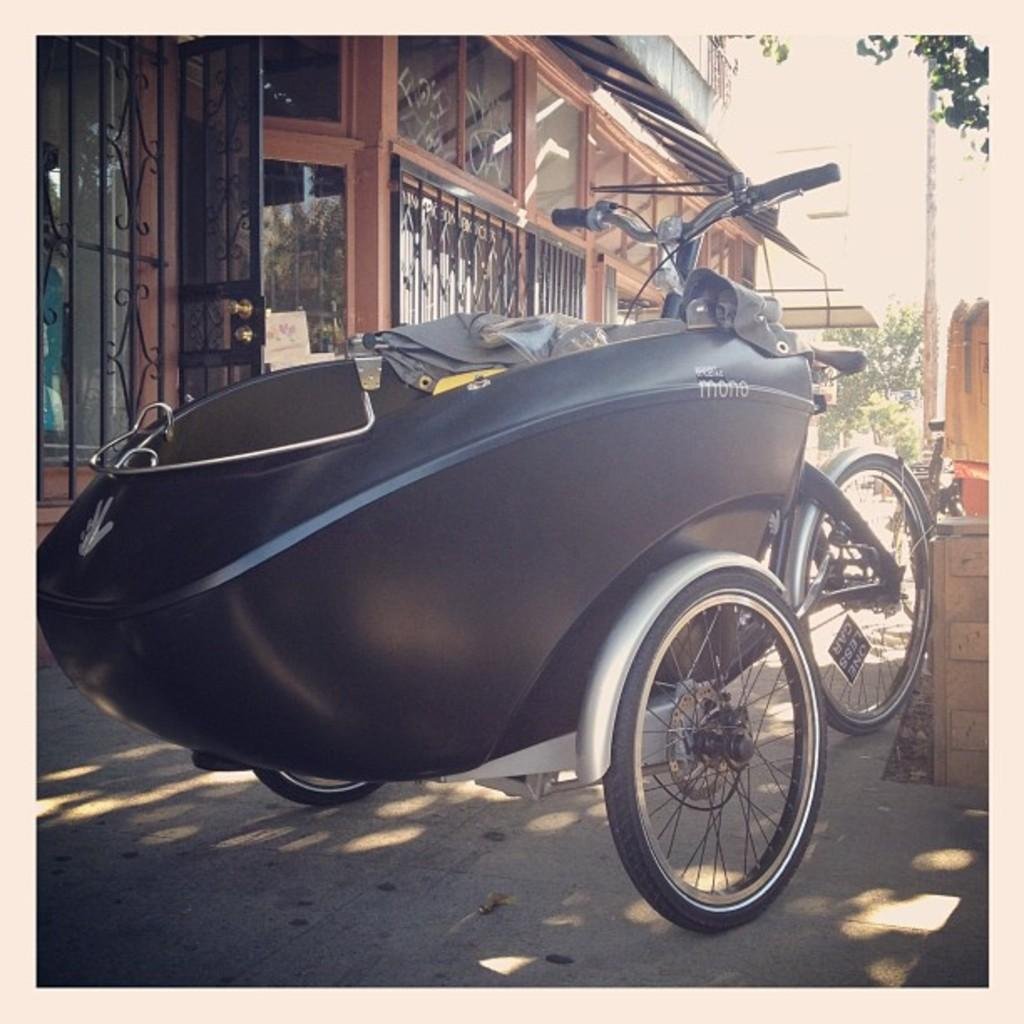What is the main subject of the image? There is a vehicle in the image. What can be seen beneath the vehicle? The ground is visible in the image. What structures are present in the background of the image? There are buildings in the image. What object is standing upright in the image? There is a pole in the image. What type of vegetation is visible in the image? There are trees in the image. What type of cracker is being served to the people in the image? There are no people or crackers present in the image. What stage of development is the city in, as seen in the image? The image does not provide information about the development stage of the city. 